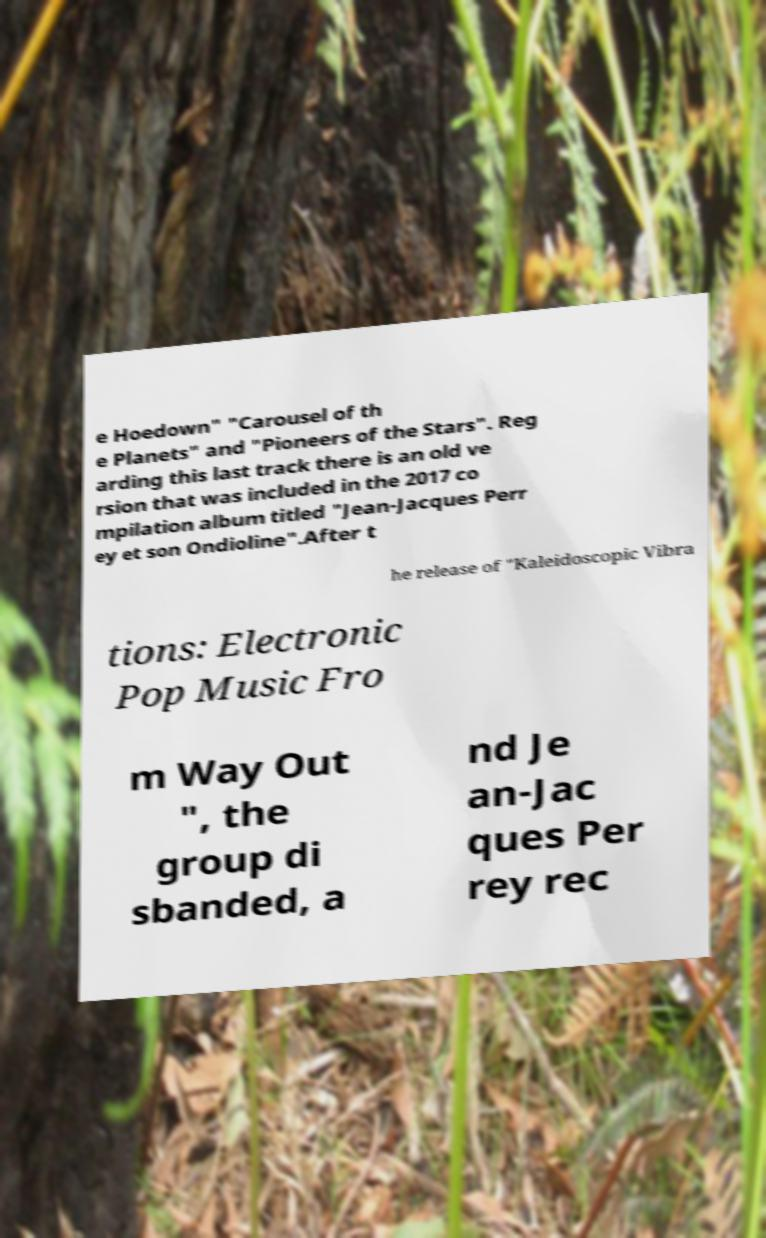What messages or text are displayed in this image? I need them in a readable, typed format. e Hoedown" "Carousel of th e Planets" and "Pioneers of the Stars". Reg arding this last track there is an old ve rsion that was included in the 2017 co mpilation album titled "Jean-Jacques Perr ey et son Ondioline".After t he release of "Kaleidoscopic Vibra tions: Electronic Pop Music Fro m Way Out ", the group di sbanded, a nd Je an-Jac ques Per rey rec 